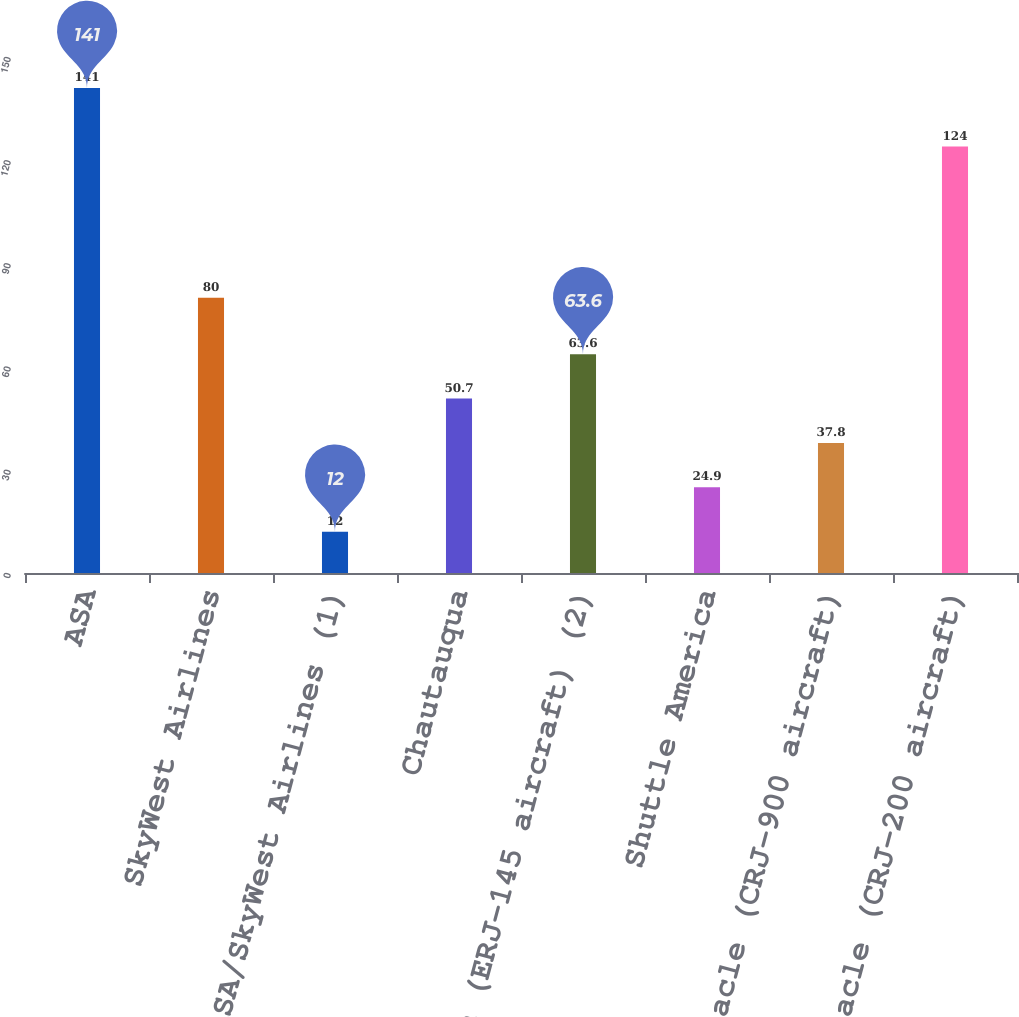<chart> <loc_0><loc_0><loc_500><loc_500><bar_chart><fcel>ASA<fcel>SkyWest Airlines<fcel>ASA/SkyWest Airlines (1)<fcel>Chautauqua<fcel>Freedom (ERJ-145 aircraft) (2)<fcel>Shuttle America<fcel>Pinnacle (CRJ-900 aircraft)<fcel>Pinnacle (CRJ-200 aircraft)<nl><fcel>141<fcel>80<fcel>12<fcel>50.7<fcel>63.6<fcel>24.9<fcel>37.8<fcel>124<nl></chart> 